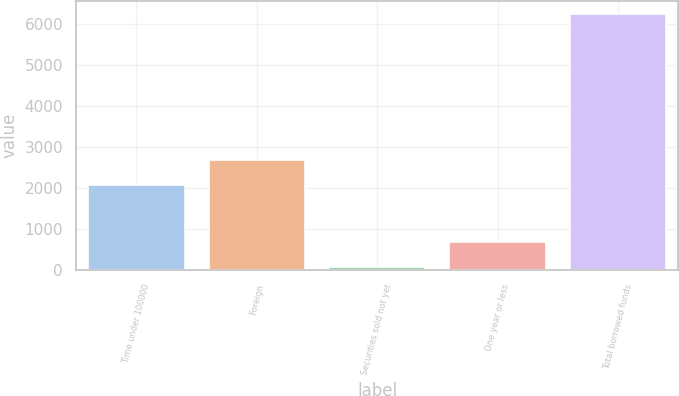<chart> <loc_0><loc_0><loc_500><loc_500><bar_chart><fcel>Time under 100000<fcel>Foreign<fcel>Securities sold not yet<fcel>One year or less<fcel>Total borrowed funds<nl><fcel>2065<fcel>2682.6<fcel>66<fcel>683.6<fcel>6242<nl></chart> 